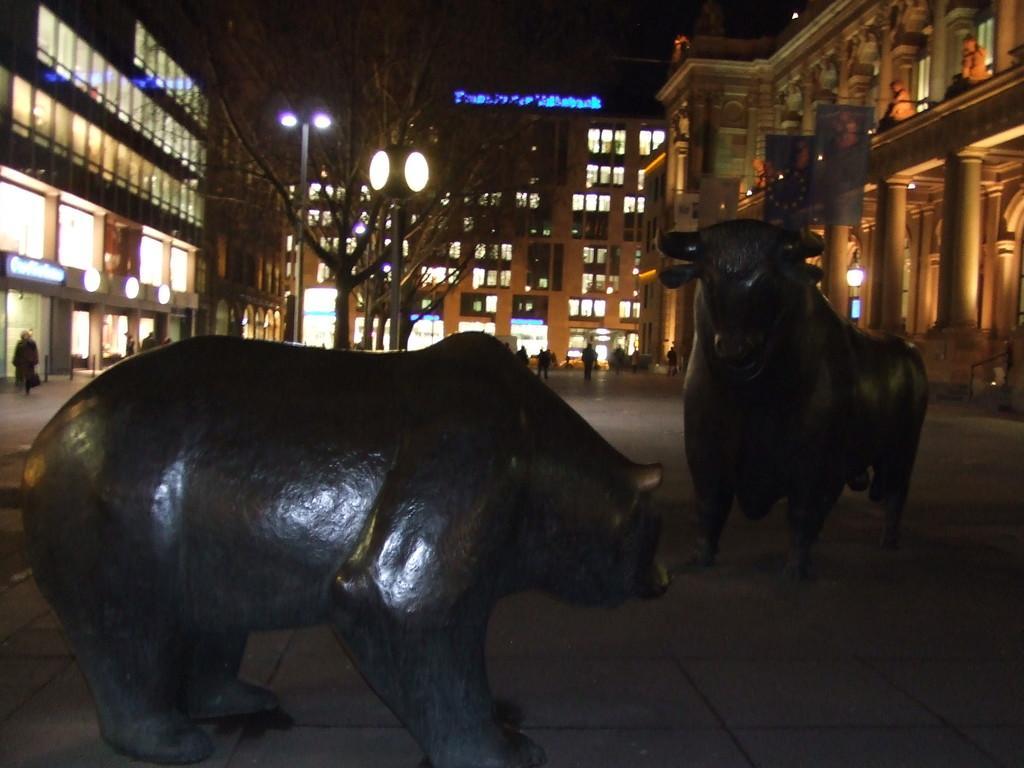Could you give a brief overview of what you see in this image? In this image in front there are two statues. Behind them there are people walking on the road. In the background of the image there are buildings, trees and lights. 